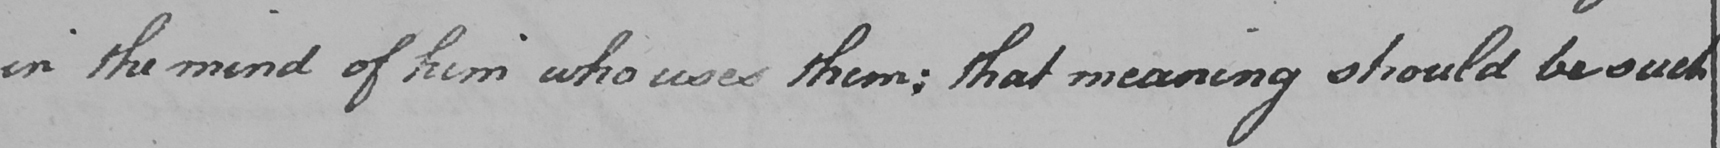Please provide the text content of this handwritten line. in the mind of him who uses them ; that meaning should be such 